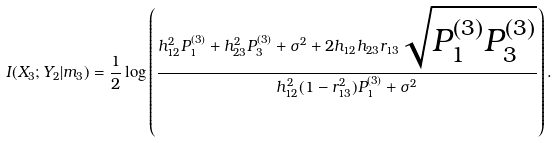Convert formula to latex. <formula><loc_0><loc_0><loc_500><loc_500>I ( X _ { 3 } ; Y _ { 2 } | m _ { 3 } ) = \frac { 1 } { 2 } \log \left ( \frac { h _ { 1 2 } ^ { 2 } P _ { 1 } ^ { ( 3 ) } + h _ { 2 3 } ^ { 2 } P _ { 3 } ^ { ( 3 ) } + \sigma ^ { 2 } + 2 h _ { 1 2 } h _ { 2 3 } r _ { 1 3 } \sqrt { P _ { 1 } ^ { ( 3 ) } P _ { 3 } ^ { ( 3 ) } } } { h _ { 1 2 } ^ { 2 } ( 1 - r _ { 1 3 } ^ { 2 } ) P _ { 1 } ^ { ( 3 ) } + \sigma ^ { 2 } } \right ) .</formula> 